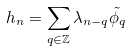<formula> <loc_0><loc_0><loc_500><loc_500>h _ { n } = \sum _ { q \in \mathbb { Z } } \lambda _ { n - q } \tilde { \phi _ { q } }</formula> 